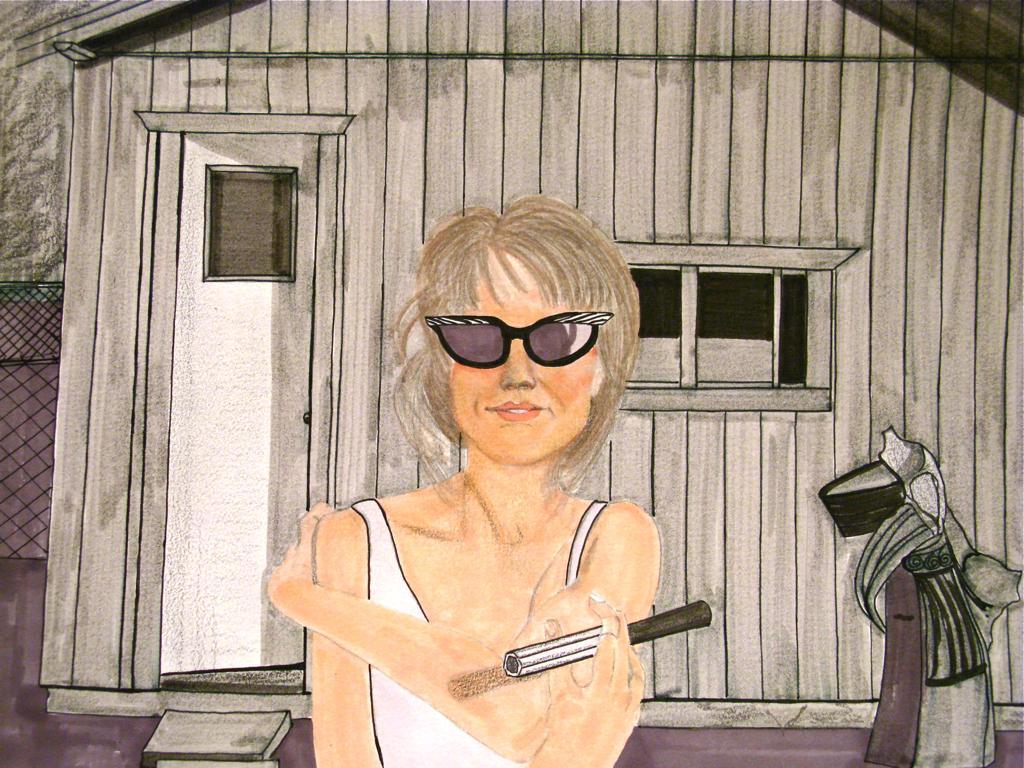How would you summarize this image in a sentence or two? In this picture there is a sketch. At the bottom, there is a woman wearing a white top and she is holding something. Towards the right, there are some objects. In the background, there is a house with door and window. 